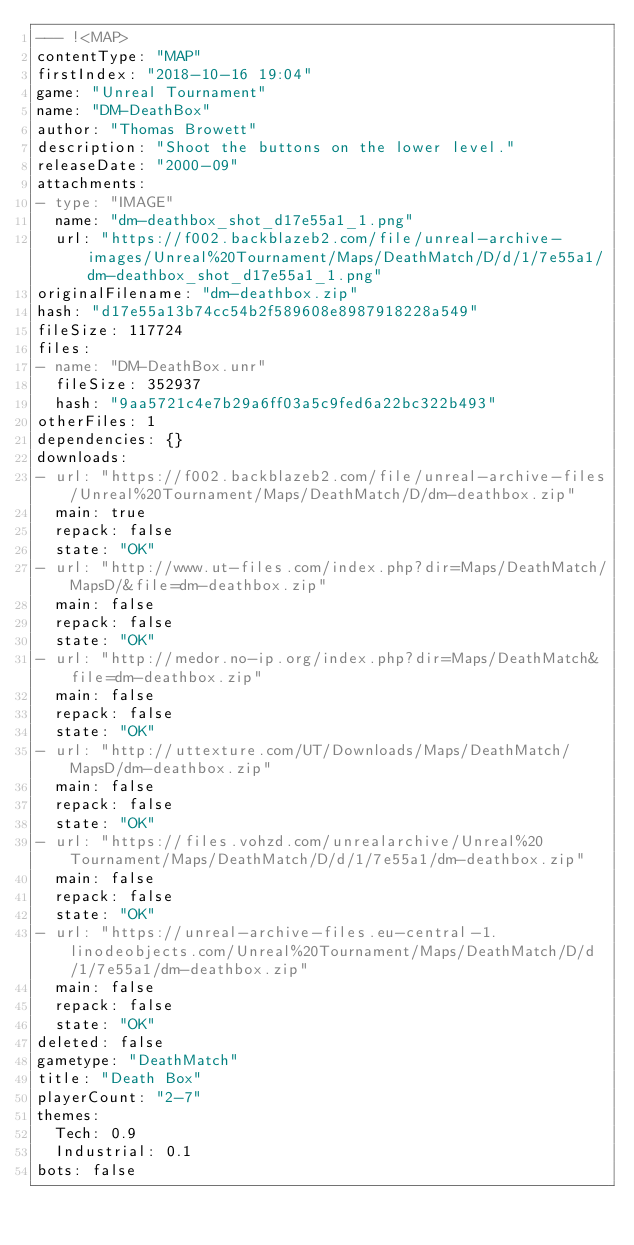Convert code to text. <code><loc_0><loc_0><loc_500><loc_500><_YAML_>--- !<MAP>
contentType: "MAP"
firstIndex: "2018-10-16 19:04"
game: "Unreal Tournament"
name: "DM-DeathBox"
author: "Thomas Browett"
description: "Shoot the buttons on the lower level."
releaseDate: "2000-09"
attachments:
- type: "IMAGE"
  name: "dm-deathbox_shot_d17e55a1_1.png"
  url: "https://f002.backblazeb2.com/file/unreal-archive-images/Unreal%20Tournament/Maps/DeathMatch/D/d/1/7e55a1/dm-deathbox_shot_d17e55a1_1.png"
originalFilename: "dm-deathbox.zip"
hash: "d17e55a13b74cc54b2f589608e8987918228a549"
fileSize: 117724
files:
- name: "DM-DeathBox.unr"
  fileSize: 352937
  hash: "9aa5721c4e7b29a6ff03a5c9fed6a22bc322b493"
otherFiles: 1
dependencies: {}
downloads:
- url: "https://f002.backblazeb2.com/file/unreal-archive-files/Unreal%20Tournament/Maps/DeathMatch/D/dm-deathbox.zip"
  main: true
  repack: false
  state: "OK"
- url: "http://www.ut-files.com/index.php?dir=Maps/DeathMatch/MapsD/&file=dm-deathbox.zip"
  main: false
  repack: false
  state: "OK"
- url: "http://medor.no-ip.org/index.php?dir=Maps/DeathMatch&file=dm-deathbox.zip"
  main: false
  repack: false
  state: "OK"
- url: "http://uttexture.com/UT/Downloads/Maps/DeathMatch/MapsD/dm-deathbox.zip"
  main: false
  repack: false
  state: "OK"
- url: "https://files.vohzd.com/unrealarchive/Unreal%20Tournament/Maps/DeathMatch/D/d/1/7e55a1/dm-deathbox.zip"
  main: false
  repack: false
  state: "OK"
- url: "https://unreal-archive-files.eu-central-1.linodeobjects.com/Unreal%20Tournament/Maps/DeathMatch/D/d/1/7e55a1/dm-deathbox.zip"
  main: false
  repack: false
  state: "OK"
deleted: false
gametype: "DeathMatch"
title: "Death Box"
playerCount: "2-7"
themes:
  Tech: 0.9
  Industrial: 0.1
bots: false
</code> 